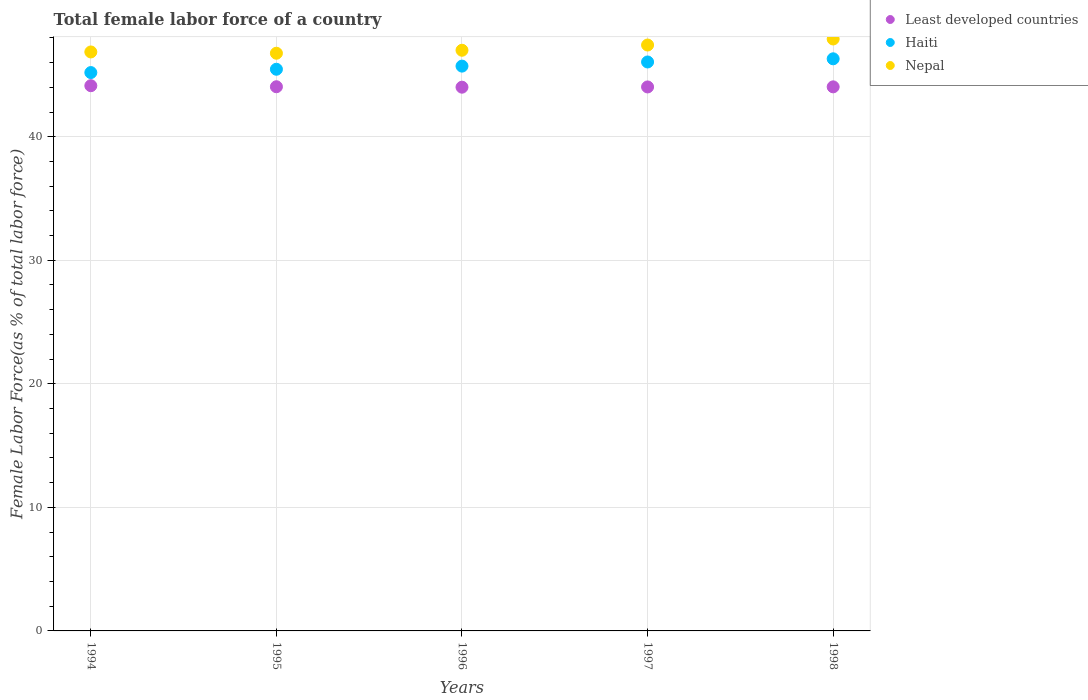How many different coloured dotlines are there?
Your answer should be compact. 3. What is the percentage of female labor force in Least developed countries in 1998?
Provide a succinct answer. 44.04. Across all years, what is the maximum percentage of female labor force in Haiti?
Your answer should be very brief. 46.31. Across all years, what is the minimum percentage of female labor force in Haiti?
Keep it short and to the point. 45.19. What is the total percentage of female labor force in Least developed countries in the graph?
Give a very brief answer. 220.26. What is the difference between the percentage of female labor force in Nepal in 1996 and that in 1998?
Provide a short and direct response. -0.91. What is the difference between the percentage of female labor force in Least developed countries in 1995 and the percentage of female labor force in Nepal in 1996?
Your answer should be compact. -2.95. What is the average percentage of female labor force in Nepal per year?
Keep it short and to the point. 47.19. In the year 1994, what is the difference between the percentage of female labor force in Nepal and percentage of female labor force in Haiti?
Offer a terse response. 1.67. What is the ratio of the percentage of female labor force in Nepal in 1997 to that in 1998?
Your answer should be very brief. 0.99. What is the difference between the highest and the second highest percentage of female labor force in Nepal?
Keep it short and to the point. 0.49. What is the difference between the highest and the lowest percentage of female labor force in Nepal?
Your response must be concise. 1.15. Does the percentage of female labor force in Least developed countries monotonically increase over the years?
Provide a succinct answer. No. Is the percentage of female labor force in Nepal strictly less than the percentage of female labor force in Least developed countries over the years?
Keep it short and to the point. No. How many dotlines are there?
Your answer should be very brief. 3. How many years are there in the graph?
Your answer should be very brief. 5. What is the difference between two consecutive major ticks on the Y-axis?
Make the answer very short. 10. Are the values on the major ticks of Y-axis written in scientific E-notation?
Provide a succinct answer. No. Does the graph contain any zero values?
Ensure brevity in your answer.  No. Does the graph contain grids?
Give a very brief answer. Yes. How are the legend labels stacked?
Your answer should be compact. Vertical. What is the title of the graph?
Your answer should be compact. Total female labor force of a country. What is the label or title of the Y-axis?
Your response must be concise. Female Labor Force(as % of total labor force). What is the Female Labor Force(as % of total labor force) in Least developed countries in 1994?
Provide a succinct answer. 44.13. What is the Female Labor Force(as % of total labor force) in Haiti in 1994?
Your response must be concise. 45.19. What is the Female Labor Force(as % of total labor force) in Nepal in 1994?
Offer a very short reply. 46.86. What is the Female Labor Force(as % of total labor force) in Least developed countries in 1995?
Your answer should be compact. 44.05. What is the Female Labor Force(as % of total labor force) of Haiti in 1995?
Offer a very short reply. 45.46. What is the Female Labor Force(as % of total labor force) of Nepal in 1995?
Provide a short and direct response. 46.76. What is the Female Labor Force(as % of total labor force) of Least developed countries in 1996?
Provide a short and direct response. 44.01. What is the Female Labor Force(as % of total labor force) in Haiti in 1996?
Give a very brief answer. 45.72. What is the Female Labor Force(as % of total labor force) in Nepal in 1996?
Your answer should be compact. 47. What is the Female Labor Force(as % of total labor force) of Least developed countries in 1997?
Ensure brevity in your answer.  44.03. What is the Female Labor Force(as % of total labor force) of Haiti in 1997?
Your response must be concise. 46.05. What is the Female Labor Force(as % of total labor force) in Nepal in 1997?
Your answer should be compact. 47.42. What is the Female Labor Force(as % of total labor force) in Least developed countries in 1998?
Your response must be concise. 44.04. What is the Female Labor Force(as % of total labor force) of Haiti in 1998?
Offer a terse response. 46.31. What is the Female Labor Force(as % of total labor force) in Nepal in 1998?
Give a very brief answer. 47.91. Across all years, what is the maximum Female Labor Force(as % of total labor force) of Least developed countries?
Keep it short and to the point. 44.13. Across all years, what is the maximum Female Labor Force(as % of total labor force) in Haiti?
Your response must be concise. 46.31. Across all years, what is the maximum Female Labor Force(as % of total labor force) of Nepal?
Give a very brief answer. 47.91. Across all years, what is the minimum Female Labor Force(as % of total labor force) of Least developed countries?
Give a very brief answer. 44.01. Across all years, what is the minimum Female Labor Force(as % of total labor force) of Haiti?
Provide a succinct answer. 45.19. Across all years, what is the minimum Female Labor Force(as % of total labor force) in Nepal?
Keep it short and to the point. 46.76. What is the total Female Labor Force(as % of total labor force) of Least developed countries in the graph?
Ensure brevity in your answer.  220.26. What is the total Female Labor Force(as % of total labor force) of Haiti in the graph?
Your answer should be compact. 228.74. What is the total Female Labor Force(as % of total labor force) of Nepal in the graph?
Offer a very short reply. 235.96. What is the difference between the Female Labor Force(as % of total labor force) of Least developed countries in 1994 and that in 1995?
Your answer should be very brief. 0.08. What is the difference between the Female Labor Force(as % of total labor force) of Haiti in 1994 and that in 1995?
Make the answer very short. -0.27. What is the difference between the Female Labor Force(as % of total labor force) in Nepal in 1994 and that in 1995?
Your answer should be compact. 0.1. What is the difference between the Female Labor Force(as % of total labor force) of Least developed countries in 1994 and that in 1996?
Offer a very short reply. 0.12. What is the difference between the Female Labor Force(as % of total labor force) of Haiti in 1994 and that in 1996?
Give a very brief answer. -0.52. What is the difference between the Female Labor Force(as % of total labor force) of Nepal in 1994 and that in 1996?
Provide a succinct answer. -0.14. What is the difference between the Female Labor Force(as % of total labor force) of Least developed countries in 1994 and that in 1997?
Your answer should be compact. 0.1. What is the difference between the Female Labor Force(as % of total labor force) of Haiti in 1994 and that in 1997?
Ensure brevity in your answer.  -0.86. What is the difference between the Female Labor Force(as % of total labor force) in Nepal in 1994 and that in 1997?
Your answer should be very brief. -0.56. What is the difference between the Female Labor Force(as % of total labor force) in Least developed countries in 1994 and that in 1998?
Your answer should be compact. 0.09. What is the difference between the Female Labor Force(as % of total labor force) of Haiti in 1994 and that in 1998?
Offer a terse response. -1.11. What is the difference between the Female Labor Force(as % of total labor force) in Nepal in 1994 and that in 1998?
Your answer should be very brief. -1.05. What is the difference between the Female Labor Force(as % of total labor force) in Least developed countries in 1995 and that in 1996?
Your answer should be compact. 0.04. What is the difference between the Female Labor Force(as % of total labor force) of Haiti in 1995 and that in 1996?
Offer a very short reply. -0.25. What is the difference between the Female Labor Force(as % of total labor force) of Nepal in 1995 and that in 1996?
Provide a short and direct response. -0.24. What is the difference between the Female Labor Force(as % of total labor force) in Least developed countries in 1995 and that in 1997?
Your answer should be compact. 0.02. What is the difference between the Female Labor Force(as % of total labor force) in Haiti in 1995 and that in 1997?
Your answer should be compact. -0.59. What is the difference between the Female Labor Force(as % of total labor force) in Nepal in 1995 and that in 1997?
Your answer should be very brief. -0.66. What is the difference between the Female Labor Force(as % of total labor force) of Least developed countries in 1995 and that in 1998?
Provide a succinct answer. 0.01. What is the difference between the Female Labor Force(as % of total labor force) of Haiti in 1995 and that in 1998?
Ensure brevity in your answer.  -0.85. What is the difference between the Female Labor Force(as % of total labor force) in Nepal in 1995 and that in 1998?
Provide a succinct answer. -1.15. What is the difference between the Female Labor Force(as % of total labor force) in Least developed countries in 1996 and that in 1997?
Provide a succinct answer. -0.02. What is the difference between the Female Labor Force(as % of total labor force) in Haiti in 1996 and that in 1997?
Offer a terse response. -0.34. What is the difference between the Female Labor Force(as % of total labor force) of Nepal in 1996 and that in 1997?
Offer a very short reply. -0.42. What is the difference between the Female Labor Force(as % of total labor force) in Least developed countries in 1996 and that in 1998?
Make the answer very short. -0.03. What is the difference between the Female Labor Force(as % of total labor force) of Haiti in 1996 and that in 1998?
Offer a very short reply. -0.59. What is the difference between the Female Labor Force(as % of total labor force) of Nepal in 1996 and that in 1998?
Make the answer very short. -0.91. What is the difference between the Female Labor Force(as % of total labor force) of Least developed countries in 1997 and that in 1998?
Provide a short and direct response. -0.01. What is the difference between the Female Labor Force(as % of total labor force) in Haiti in 1997 and that in 1998?
Provide a short and direct response. -0.26. What is the difference between the Female Labor Force(as % of total labor force) in Nepal in 1997 and that in 1998?
Offer a very short reply. -0.49. What is the difference between the Female Labor Force(as % of total labor force) of Least developed countries in 1994 and the Female Labor Force(as % of total labor force) of Haiti in 1995?
Your answer should be compact. -1.33. What is the difference between the Female Labor Force(as % of total labor force) in Least developed countries in 1994 and the Female Labor Force(as % of total labor force) in Nepal in 1995?
Offer a very short reply. -2.63. What is the difference between the Female Labor Force(as % of total labor force) in Haiti in 1994 and the Female Labor Force(as % of total labor force) in Nepal in 1995?
Offer a very short reply. -1.57. What is the difference between the Female Labor Force(as % of total labor force) in Least developed countries in 1994 and the Female Labor Force(as % of total labor force) in Haiti in 1996?
Offer a very short reply. -1.59. What is the difference between the Female Labor Force(as % of total labor force) in Least developed countries in 1994 and the Female Labor Force(as % of total labor force) in Nepal in 1996?
Your response must be concise. -2.87. What is the difference between the Female Labor Force(as % of total labor force) in Haiti in 1994 and the Female Labor Force(as % of total labor force) in Nepal in 1996?
Provide a short and direct response. -1.81. What is the difference between the Female Labor Force(as % of total labor force) of Least developed countries in 1994 and the Female Labor Force(as % of total labor force) of Haiti in 1997?
Keep it short and to the point. -1.92. What is the difference between the Female Labor Force(as % of total labor force) in Least developed countries in 1994 and the Female Labor Force(as % of total labor force) in Nepal in 1997?
Provide a short and direct response. -3.29. What is the difference between the Female Labor Force(as % of total labor force) of Haiti in 1994 and the Female Labor Force(as % of total labor force) of Nepal in 1997?
Make the answer very short. -2.23. What is the difference between the Female Labor Force(as % of total labor force) of Least developed countries in 1994 and the Female Labor Force(as % of total labor force) of Haiti in 1998?
Make the answer very short. -2.18. What is the difference between the Female Labor Force(as % of total labor force) of Least developed countries in 1994 and the Female Labor Force(as % of total labor force) of Nepal in 1998?
Keep it short and to the point. -3.78. What is the difference between the Female Labor Force(as % of total labor force) of Haiti in 1994 and the Female Labor Force(as % of total labor force) of Nepal in 1998?
Make the answer very short. -2.72. What is the difference between the Female Labor Force(as % of total labor force) of Least developed countries in 1995 and the Female Labor Force(as % of total labor force) of Haiti in 1996?
Make the answer very short. -1.67. What is the difference between the Female Labor Force(as % of total labor force) of Least developed countries in 1995 and the Female Labor Force(as % of total labor force) of Nepal in 1996?
Your answer should be very brief. -2.95. What is the difference between the Female Labor Force(as % of total labor force) in Haiti in 1995 and the Female Labor Force(as % of total labor force) in Nepal in 1996?
Ensure brevity in your answer.  -1.54. What is the difference between the Female Labor Force(as % of total labor force) in Least developed countries in 1995 and the Female Labor Force(as % of total labor force) in Haiti in 1997?
Give a very brief answer. -2. What is the difference between the Female Labor Force(as % of total labor force) of Least developed countries in 1995 and the Female Labor Force(as % of total labor force) of Nepal in 1997?
Provide a short and direct response. -3.38. What is the difference between the Female Labor Force(as % of total labor force) in Haiti in 1995 and the Female Labor Force(as % of total labor force) in Nepal in 1997?
Ensure brevity in your answer.  -1.96. What is the difference between the Female Labor Force(as % of total labor force) in Least developed countries in 1995 and the Female Labor Force(as % of total labor force) in Haiti in 1998?
Offer a terse response. -2.26. What is the difference between the Female Labor Force(as % of total labor force) in Least developed countries in 1995 and the Female Labor Force(as % of total labor force) in Nepal in 1998?
Your response must be concise. -3.87. What is the difference between the Female Labor Force(as % of total labor force) in Haiti in 1995 and the Female Labor Force(as % of total labor force) in Nepal in 1998?
Keep it short and to the point. -2.45. What is the difference between the Female Labor Force(as % of total labor force) in Least developed countries in 1996 and the Female Labor Force(as % of total labor force) in Haiti in 1997?
Your answer should be very brief. -2.04. What is the difference between the Female Labor Force(as % of total labor force) of Least developed countries in 1996 and the Female Labor Force(as % of total labor force) of Nepal in 1997?
Give a very brief answer. -3.41. What is the difference between the Female Labor Force(as % of total labor force) of Haiti in 1996 and the Female Labor Force(as % of total labor force) of Nepal in 1997?
Give a very brief answer. -1.71. What is the difference between the Female Labor Force(as % of total labor force) in Least developed countries in 1996 and the Female Labor Force(as % of total labor force) in Haiti in 1998?
Ensure brevity in your answer.  -2.3. What is the difference between the Female Labor Force(as % of total labor force) of Least developed countries in 1996 and the Female Labor Force(as % of total labor force) of Nepal in 1998?
Ensure brevity in your answer.  -3.9. What is the difference between the Female Labor Force(as % of total labor force) in Haiti in 1996 and the Female Labor Force(as % of total labor force) in Nepal in 1998?
Keep it short and to the point. -2.2. What is the difference between the Female Labor Force(as % of total labor force) in Least developed countries in 1997 and the Female Labor Force(as % of total labor force) in Haiti in 1998?
Give a very brief answer. -2.28. What is the difference between the Female Labor Force(as % of total labor force) of Least developed countries in 1997 and the Female Labor Force(as % of total labor force) of Nepal in 1998?
Give a very brief answer. -3.88. What is the difference between the Female Labor Force(as % of total labor force) of Haiti in 1997 and the Female Labor Force(as % of total labor force) of Nepal in 1998?
Your answer should be very brief. -1.86. What is the average Female Labor Force(as % of total labor force) in Least developed countries per year?
Keep it short and to the point. 44.05. What is the average Female Labor Force(as % of total labor force) in Haiti per year?
Make the answer very short. 45.75. What is the average Female Labor Force(as % of total labor force) in Nepal per year?
Give a very brief answer. 47.19. In the year 1994, what is the difference between the Female Labor Force(as % of total labor force) of Least developed countries and Female Labor Force(as % of total labor force) of Haiti?
Your response must be concise. -1.06. In the year 1994, what is the difference between the Female Labor Force(as % of total labor force) of Least developed countries and Female Labor Force(as % of total labor force) of Nepal?
Your answer should be compact. -2.73. In the year 1994, what is the difference between the Female Labor Force(as % of total labor force) in Haiti and Female Labor Force(as % of total labor force) in Nepal?
Ensure brevity in your answer.  -1.67. In the year 1995, what is the difference between the Female Labor Force(as % of total labor force) of Least developed countries and Female Labor Force(as % of total labor force) of Haiti?
Make the answer very short. -1.42. In the year 1995, what is the difference between the Female Labor Force(as % of total labor force) in Least developed countries and Female Labor Force(as % of total labor force) in Nepal?
Provide a succinct answer. -2.71. In the year 1995, what is the difference between the Female Labor Force(as % of total labor force) of Haiti and Female Labor Force(as % of total labor force) of Nepal?
Your answer should be compact. -1.3. In the year 1996, what is the difference between the Female Labor Force(as % of total labor force) of Least developed countries and Female Labor Force(as % of total labor force) of Haiti?
Your answer should be very brief. -1.7. In the year 1996, what is the difference between the Female Labor Force(as % of total labor force) of Least developed countries and Female Labor Force(as % of total labor force) of Nepal?
Provide a succinct answer. -2.99. In the year 1996, what is the difference between the Female Labor Force(as % of total labor force) of Haiti and Female Labor Force(as % of total labor force) of Nepal?
Your answer should be compact. -1.28. In the year 1997, what is the difference between the Female Labor Force(as % of total labor force) in Least developed countries and Female Labor Force(as % of total labor force) in Haiti?
Offer a very short reply. -2.02. In the year 1997, what is the difference between the Female Labor Force(as % of total labor force) in Least developed countries and Female Labor Force(as % of total labor force) in Nepal?
Offer a very short reply. -3.39. In the year 1997, what is the difference between the Female Labor Force(as % of total labor force) of Haiti and Female Labor Force(as % of total labor force) of Nepal?
Your answer should be very brief. -1.37. In the year 1998, what is the difference between the Female Labor Force(as % of total labor force) of Least developed countries and Female Labor Force(as % of total labor force) of Haiti?
Provide a short and direct response. -2.27. In the year 1998, what is the difference between the Female Labor Force(as % of total labor force) of Least developed countries and Female Labor Force(as % of total labor force) of Nepal?
Provide a short and direct response. -3.87. In the year 1998, what is the difference between the Female Labor Force(as % of total labor force) in Haiti and Female Labor Force(as % of total labor force) in Nepal?
Your answer should be very brief. -1.6. What is the ratio of the Female Labor Force(as % of total labor force) of Least developed countries in 1994 to that in 1995?
Your response must be concise. 1. What is the ratio of the Female Labor Force(as % of total labor force) of Nepal in 1994 to that in 1995?
Provide a succinct answer. 1. What is the ratio of the Female Labor Force(as % of total labor force) in Least developed countries in 1994 to that in 1996?
Your response must be concise. 1. What is the ratio of the Female Labor Force(as % of total labor force) in Haiti in 1994 to that in 1996?
Provide a succinct answer. 0.99. What is the ratio of the Female Labor Force(as % of total labor force) in Haiti in 1994 to that in 1997?
Your answer should be compact. 0.98. What is the ratio of the Female Labor Force(as % of total labor force) in Nepal in 1994 to that in 1997?
Offer a very short reply. 0.99. What is the ratio of the Female Labor Force(as % of total labor force) of Least developed countries in 1994 to that in 1998?
Your answer should be very brief. 1. What is the ratio of the Female Labor Force(as % of total labor force) in Haiti in 1994 to that in 1998?
Give a very brief answer. 0.98. What is the ratio of the Female Labor Force(as % of total labor force) of Nepal in 1994 to that in 1998?
Your answer should be very brief. 0.98. What is the ratio of the Female Labor Force(as % of total labor force) in Least developed countries in 1995 to that in 1996?
Offer a terse response. 1. What is the ratio of the Female Labor Force(as % of total labor force) in Nepal in 1995 to that in 1996?
Provide a succinct answer. 0.99. What is the ratio of the Female Labor Force(as % of total labor force) of Least developed countries in 1995 to that in 1997?
Provide a short and direct response. 1. What is the ratio of the Female Labor Force(as % of total labor force) in Haiti in 1995 to that in 1997?
Offer a very short reply. 0.99. What is the ratio of the Female Labor Force(as % of total labor force) in Nepal in 1995 to that in 1997?
Offer a terse response. 0.99. What is the ratio of the Female Labor Force(as % of total labor force) of Least developed countries in 1995 to that in 1998?
Offer a very short reply. 1. What is the ratio of the Female Labor Force(as % of total labor force) of Haiti in 1995 to that in 1998?
Keep it short and to the point. 0.98. What is the ratio of the Female Labor Force(as % of total labor force) of Nepal in 1995 to that in 1998?
Offer a terse response. 0.98. What is the ratio of the Female Labor Force(as % of total labor force) of Nepal in 1996 to that in 1997?
Your response must be concise. 0.99. What is the ratio of the Female Labor Force(as % of total labor force) in Haiti in 1996 to that in 1998?
Keep it short and to the point. 0.99. What is the ratio of the Female Labor Force(as % of total labor force) of Nepal in 1996 to that in 1998?
Your response must be concise. 0.98. What is the ratio of the Female Labor Force(as % of total labor force) in Haiti in 1997 to that in 1998?
Your answer should be compact. 0.99. What is the difference between the highest and the second highest Female Labor Force(as % of total labor force) of Least developed countries?
Your answer should be very brief. 0.08. What is the difference between the highest and the second highest Female Labor Force(as % of total labor force) in Haiti?
Offer a very short reply. 0.26. What is the difference between the highest and the second highest Female Labor Force(as % of total labor force) in Nepal?
Your response must be concise. 0.49. What is the difference between the highest and the lowest Female Labor Force(as % of total labor force) of Least developed countries?
Your response must be concise. 0.12. What is the difference between the highest and the lowest Female Labor Force(as % of total labor force) of Haiti?
Your answer should be very brief. 1.11. What is the difference between the highest and the lowest Female Labor Force(as % of total labor force) in Nepal?
Your answer should be very brief. 1.15. 